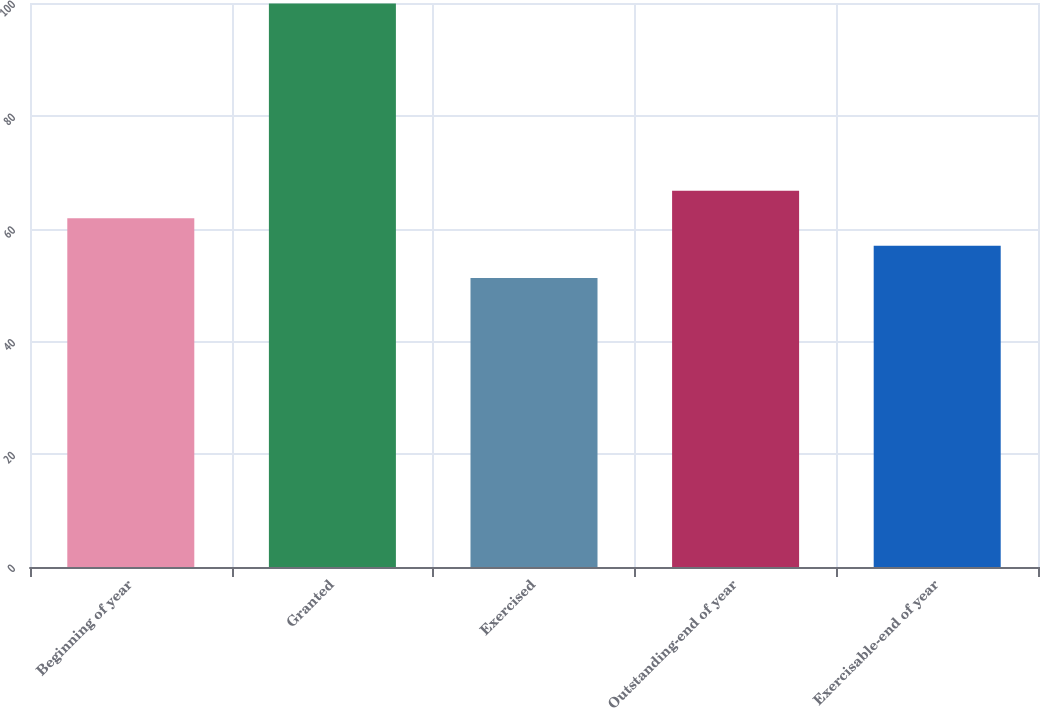Convert chart. <chart><loc_0><loc_0><loc_500><loc_500><bar_chart><fcel>Beginning of year<fcel>Granted<fcel>Exercised<fcel>Outstanding-end of year<fcel>Exercisable-end of year<nl><fcel>61.84<fcel>99.92<fcel>51.26<fcel>66.71<fcel>56.97<nl></chart> 